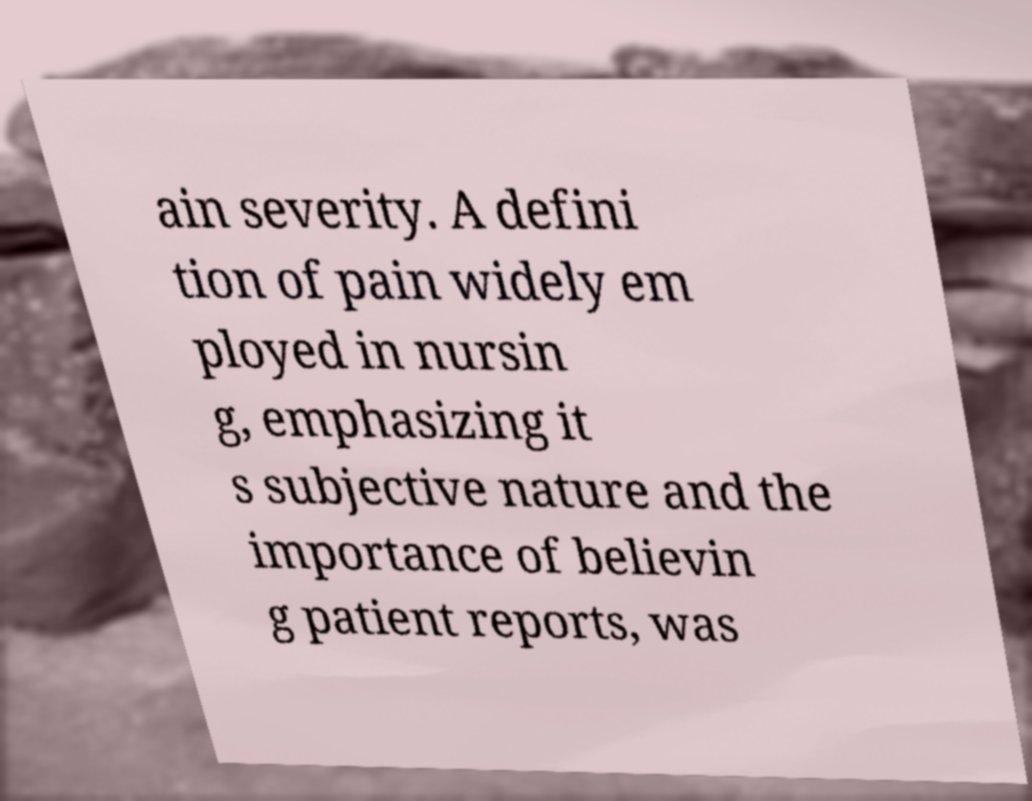Can you read and provide the text displayed in the image?This photo seems to have some interesting text. Can you extract and type it out for me? ain severity. A defini tion of pain widely em ployed in nursin g, emphasizing it s subjective nature and the importance of believin g patient reports, was 